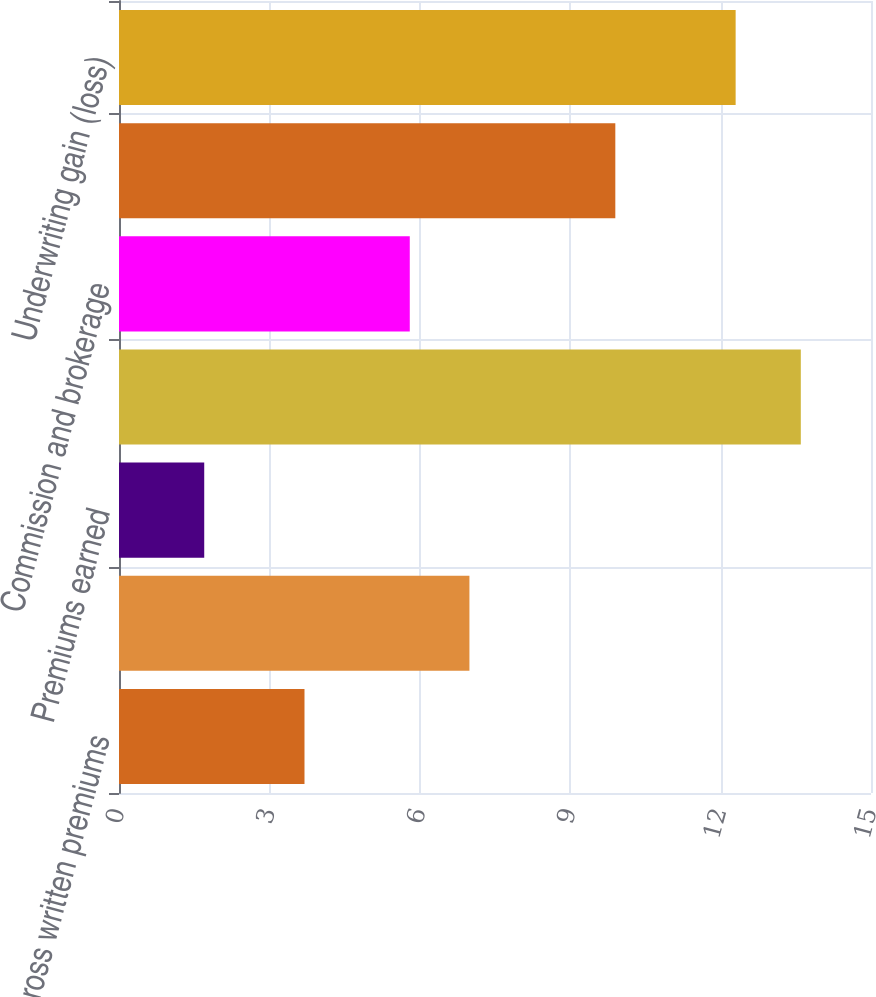<chart> <loc_0><loc_0><loc_500><loc_500><bar_chart><fcel>Gross written premiums<fcel>Net written premiums<fcel>Premiums earned<fcel>Incurred losses and LAE<fcel>Commission and brokerage<fcel>Other underwriting expenses<fcel>Underwriting gain (loss)<nl><fcel>3.7<fcel>6.99<fcel>1.7<fcel>13.6<fcel>5.8<fcel>9.9<fcel>12.3<nl></chart> 